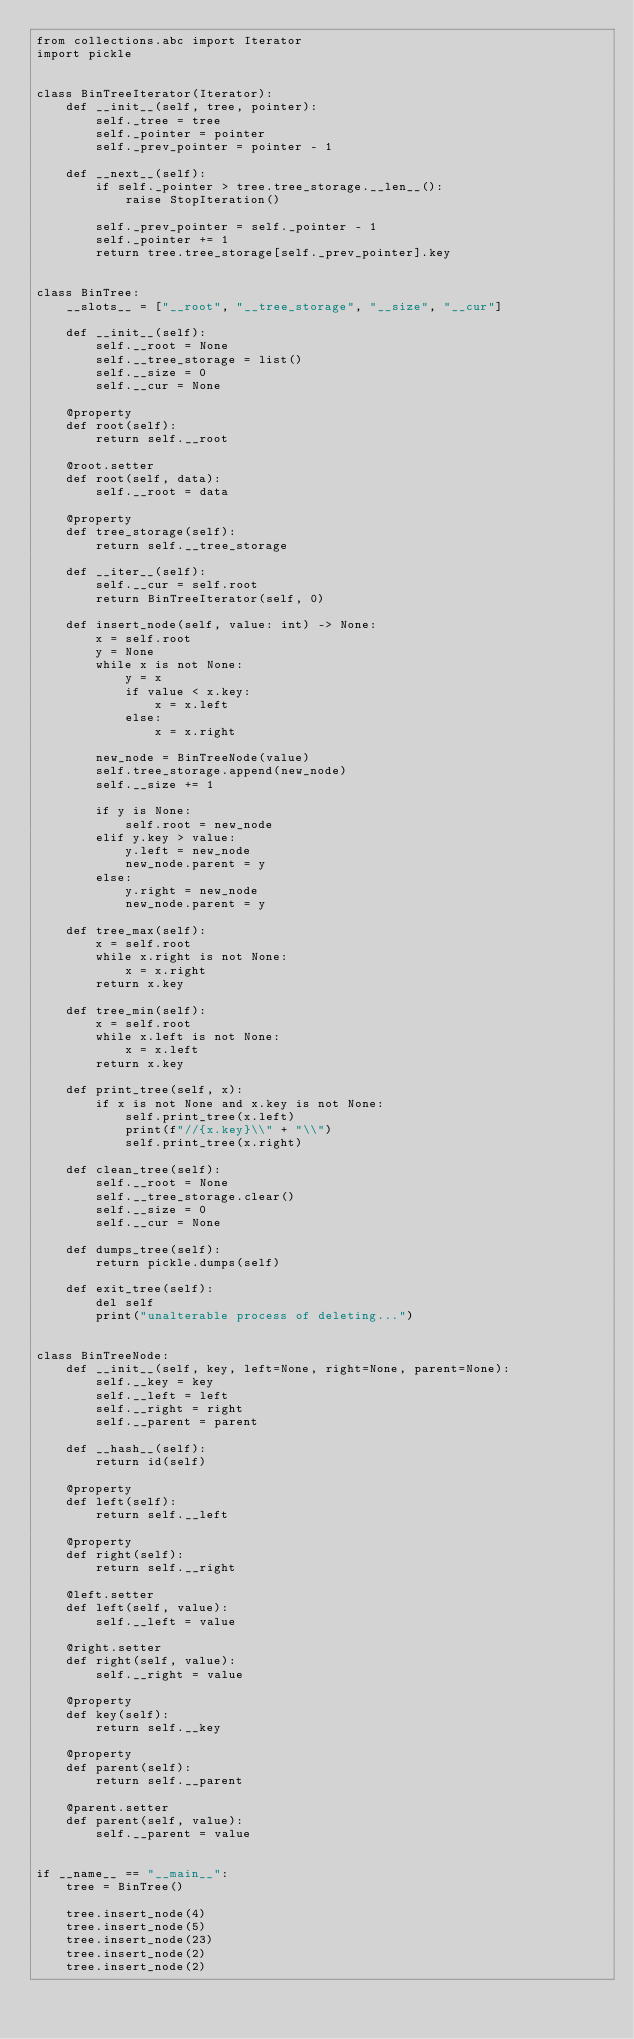<code> <loc_0><loc_0><loc_500><loc_500><_Python_>from collections.abc import Iterator
import pickle


class BinTreeIterator(Iterator):
    def __init__(self, tree, pointer):
        self._tree = tree
        self._pointer = pointer
        self._prev_pointer = pointer - 1

    def __next__(self):
        if self._pointer > tree.tree_storage.__len__():
            raise StopIteration()

        self._prev_pointer = self._pointer - 1
        self._pointer += 1
        return tree.tree_storage[self._prev_pointer].key


class BinTree:
    __slots__ = ["__root", "__tree_storage", "__size", "__cur"]

    def __init__(self):
        self.__root = None
        self.__tree_storage = list()
        self.__size = 0
        self.__cur = None

    @property
    def root(self):
        return self.__root

    @root.setter
    def root(self, data):
        self.__root = data

    @property
    def tree_storage(self):
        return self.__tree_storage

    def __iter__(self):
        self.__cur = self.root
        return BinTreeIterator(self, 0)

    def insert_node(self, value: int) -> None:
        x = self.root
        y = None
        while x is not None:
            y = x
            if value < x.key:
                x = x.left
            else:
                x = x.right

        new_node = BinTreeNode(value)
        self.tree_storage.append(new_node)
        self.__size += 1

        if y is None:
            self.root = new_node
        elif y.key > value:
            y.left = new_node
            new_node.parent = y
        else:
            y.right = new_node
            new_node.parent = y

    def tree_max(self):
        x = self.root
        while x.right is not None:
            x = x.right
        return x.key

    def tree_min(self):
        x = self.root
        while x.left is not None:
            x = x.left
        return x.key

    def print_tree(self, x):
        if x is not None and x.key is not None:
            self.print_tree(x.left)
            print(f"//{x.key}\\" + "\\")
            self.print_tree(x.right)

    def clean_tree(self):
        self.__root = None
        self.__tree_storage.clear()
        self.__size = 0
        self.__cur = None

    def dumps_tree(self):
        return pickle.dumps(self)

    def exit_tree(self):
        del self
        print("unalterable process of deleting...")


class BinTreeNode:
    def __init__(self, key, left=None, right=None, parent=None):
        self.__key = key
        self.__left = left
        self.__right = right
        self.__parent = parent

    def __hash__(self):
        return id(self)

    @property
    def left(self):
        return self.__left

    @property
    def right(self):
        return self.__right

    @left.setter
    def left(self, value):
        self.__left = value

    @right.setter
    def right(self, value):
        self.__right = value

    @property
    def key(self):
        return self.__key

    @property
    def parent(self):
        return self.__parent

    @parent.setter
    def parent(self, value):
        self.__parent = value


if __name__ == "__main__":
    tree = BinTree()

    tree.insert_node(4)
    tree.insert_node(5)
    tree.insert_node(23)
    tree.insert_node(2)
    tree.insert_node(2)</code> 